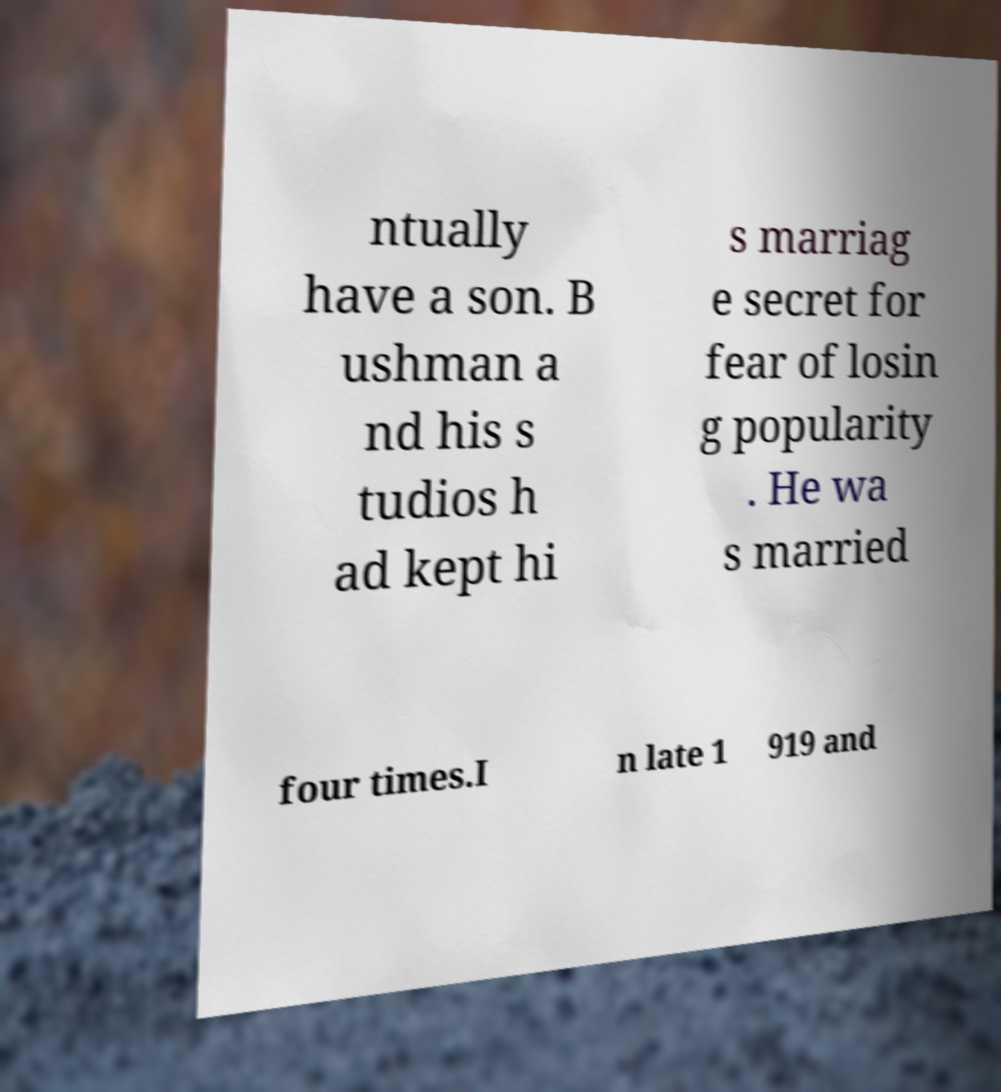For documentation purposes, I need the text within this image transcribed. Could you provide that? ntually have a son. B ushman a nd his s tudios h ad kept hi s marriag e secret for fear of losin g popularity . He wa s married four times.I n late 1 919 and 